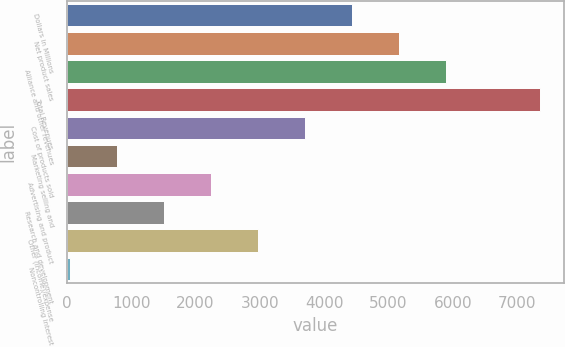Convert chart to OTSL. <chart><loc_0><loc_0><loc_500><loc_500><bar_chart><fcel>Dollars in Millions<fcel>Net product sales<fcel>Alliance and other revenues<fcel>Total Revenues<fcel>Cost of products sold<fcel>Marketing selling and<fcel>Advertising and product<fcel>Research and development<fcel>Other (income)/expense<fcel>Noncontrolling interest<nl><fcel>4430.6<fcel>5162.7<fcel>5894.8<fcel>7359<fcel>3698.5<fcel>770.1<fcel>2234.3<fcel>1502.2<fcel>2966.4<fcel>38<nl></chart> 